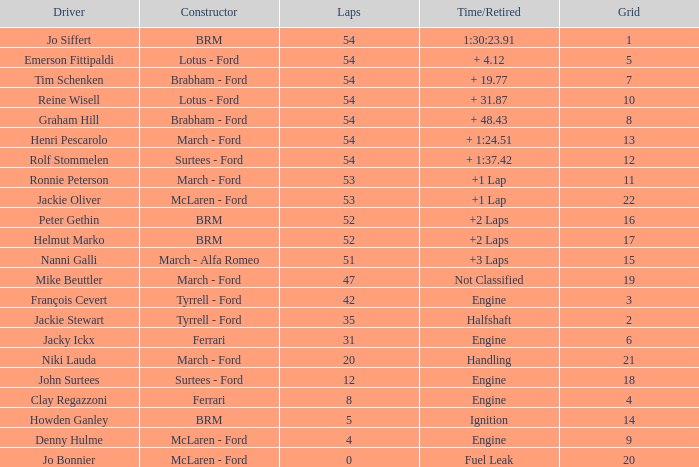How many laps for a grid larger than 1 with a Time/Retired of halfshaft? 35.0. 